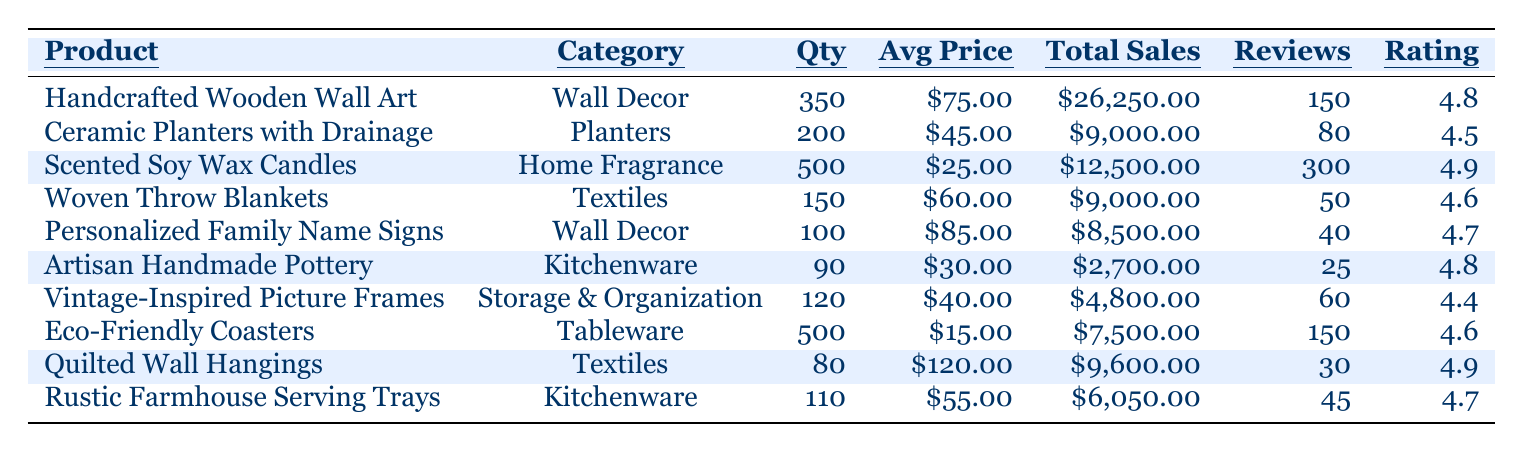What is the best-selling product based on sales quantity? By looking at the "Sales Quantity" column, the product with the highest quantity sold is "Scented Soy Wax Candles" with 500 units.
Answer: Scented Soy Wax Candles How much total sales did "Ceramic Planters with Drainage" generate? The "Total Sales" for "Ceramic Planters with Drainage" is clearly listed in the table as $9,000.00.
Answer: $9,000.00 Which product has the highest average rating? By comparing the "Average Rating" of all products, "Scented Soy Wax Candles" and "Quilted Wall Hangings" both have a rating of 4.9, which is the highest.
Answer: Scented Soy Wax Candles and Quilted Wall Hangings What is the average price of products in the Kitchenware category? For Kitchenware, the average price is calculated as follows: (30 + 55) / 2 = 42.50.
Answer: $42.50 How many customer reviews did "Woven Throw Blankets" receive? Referring to the "Customer Reviews" column, "Woven Throw Blankets" has 50 reviews.
Answer: 50 Is the average rating of "Vintage-Inspired Picture Frames" above 4.5? The average rating for "Vintage-Inspired Picture Frames" is 4.4, which is below 4.5, making the statement false.
Answer: No Which category has the highest total sales? The total sales by category are: Wall Decor ($34,750.00), Planters ($9,000.00), Home Fragrance ($12,500.00), Textiles ($15,600.00), Kitchenware ($8,750.00), Storage & Organization ($4,800.00), and Tableware ($7,500.00). Wall Decor has the highest total sales at $34,750.00.
Answer: Wall Decor What is the total sales from the products with an average rating of 4.8 or higher? The applicable products are "Handcrafted Wooden Wall Art," "Scented Soy Wax Candles," "Artisan Handmade Pottery," "Quilted Wall Hangings," and "Rustic Farmhouse Serving Trays." Total sales are: $26,250 + $12,500 + $2,700 + $9,600 + $6,050 = $56,100.
Answer: $56,100 How many more sales did "Eco-Friendly Coasters" have than "Artisan Handmade Pottery"? "Eco-Friendly Coasters" sold 500 units and "Artisan Handmade Pottery" sold 90 units. The difference in sales is 500 - 90 = 410 units.
Answer: 410 units Which product is positioned in the Wall Decor category with the least total sales? Among the products in the Wall Decor category, "Personalized Family Name Signs" has the lowest total sales of $8,500.00 compared to "Handcrafted Wooden Wall Art" ($26,250.00).
Answer: Personalized Family Name Signs What is the total customer reviews for products in the Textiles category? The products in the Textiles category are "Woven Throw Blankets" (50 reviews) and "Quilted Wall Hangings" (30 reviews). Total reviews are: 50 + 30 = 80.
Answer: 80 reviews 